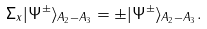<formula> <loc_0><loc_0><loc_500><loc_500>\Sigma _ { x } | \Psi ^ { \pm } \rangle _ { A _ { 2 } - A _ { 3 } } = \pm | \Psi ^ { \pm } \rangle _ { A _ { 2 } - A _ { 3 } } .</formula> 